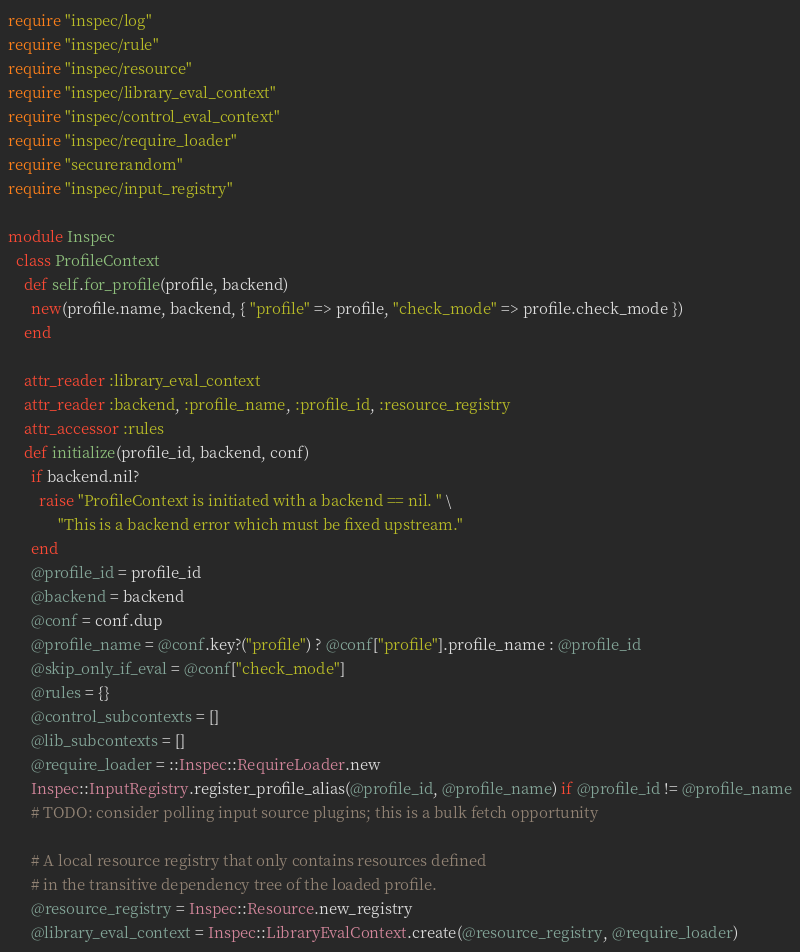Convert code to text. <code><loc_0><loc_0><loc_500><loc_500><_Ruby_>require "inspec/log"
require "inspec/rule"
require "inspec/resource"
require "inspec/library_eval_context"
require "inspec/control_eval_context"
require "inspec/require_loader"
require "securerandom"
require "inspec/input_registry"

module Inspec
  class ProfileContext
    def self.for_profile(profile, backend)
      new(profile.name, backend, { "profile" => profile, "check_mode" => profile.check_mode })
    end

    attr_reader :library_eval_context
    attr_reader :backend, :profile_name, :profile_id, :resource_registry
    attr_accessor :rules
    def initialize(profile_id, backend, conf)
      if backend.nil?
        raise "ProfileContext is initiated with a backend == nil. " \
             "This is a backend error which must be fixed upstream."
      end
      @profile_id = profile_id
      @backend = backend
      @conf = conf.dup
      @profile_name = @conf.key?("profile") ? @conf["profile"].profile_name : @profile_id
      @skip_only_if_eval = @conf["check_mode"]
      @rules = {}
      @control_subcontexts = []
      @lib_subcontexts = []
      @require_loader = ::Inspec::RequireLoader.new
      Inspec::InputRegistry.register_profile_alias(@profile_id, @profile_name) if @profile_id != @profile_name
      # TODO: consider polling input source plugins; this is a bulk fetch opportunity

      # A local resource registry that only contains resources defined
      # in the transitive dependency tree of the loaded profile.
      @resource_registry = Inspec::Resource.new_registry
      @library_eval_context = Inspec::LibraryEvalContext.create(@resource_registry, @require_loader)</code> 